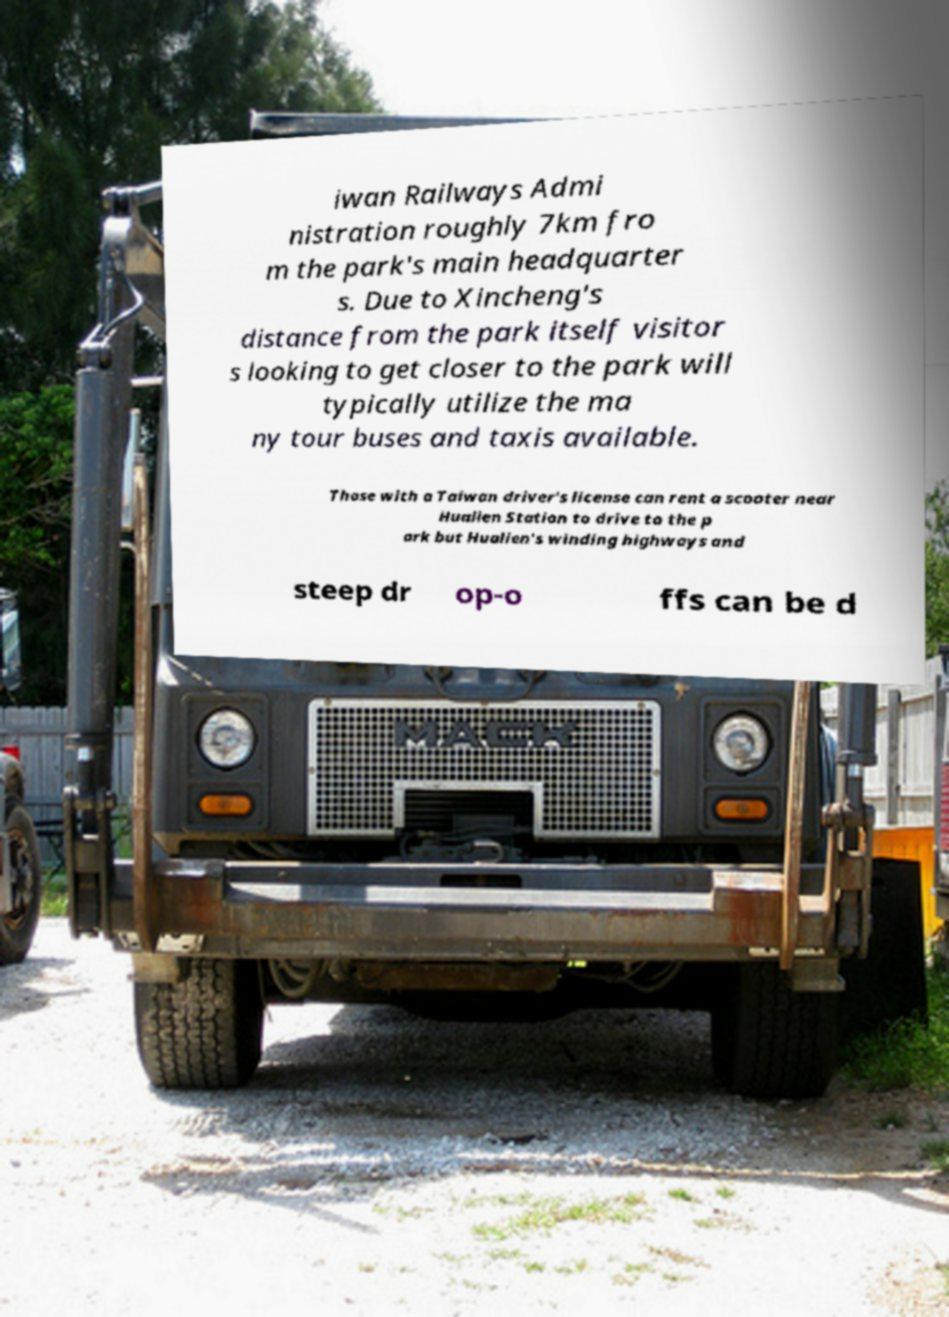For documentation purposes, I need the text within this image transcribed. Could you provide that? iwan Railways Admi nistration roughly 7km fro m the park's main headquarter s. Due to Xincheng's distance from the park itself visitor s looking to get closer to the park will typically utilize the ma ny tour buses and taxis available. Those with a Taiwan driver's license can rent a scooter near Hualien Station to drive to the p ark but Hualien's winding highways and steep dr op-o ffs can be d 